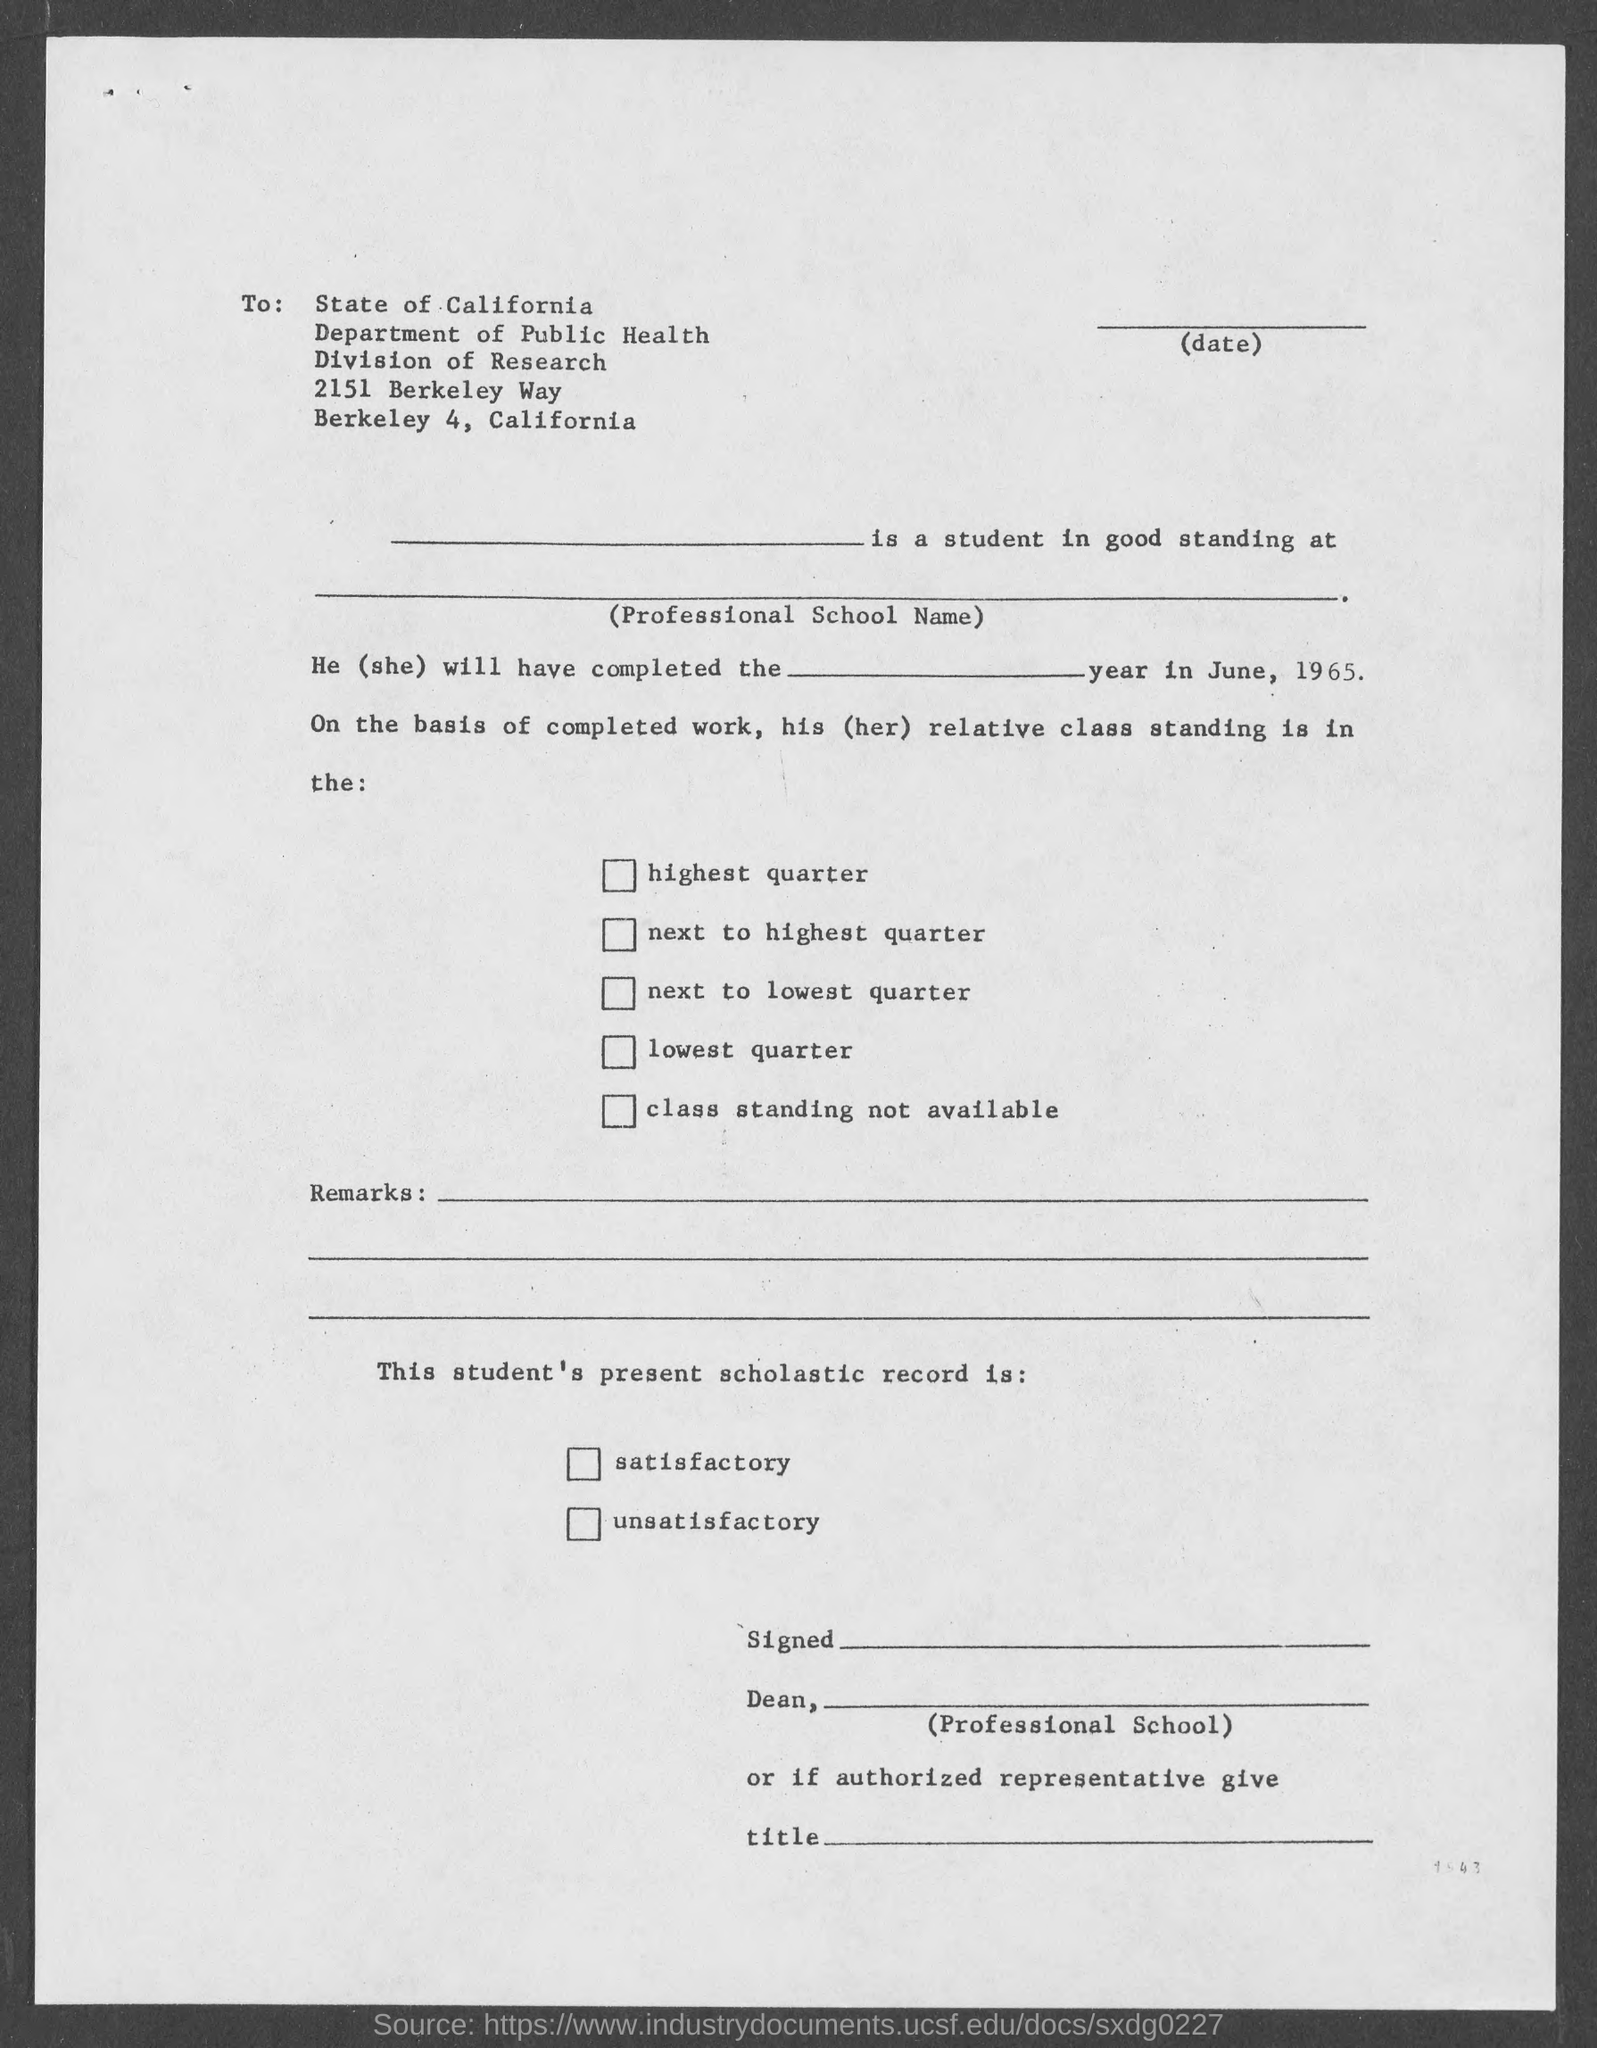What is the name of the department mentioned in the given form ?
Make the answer very short. Department of Public Health. What is the division mentioned in the given form ?
Provide a succinct answer. Division of research. 